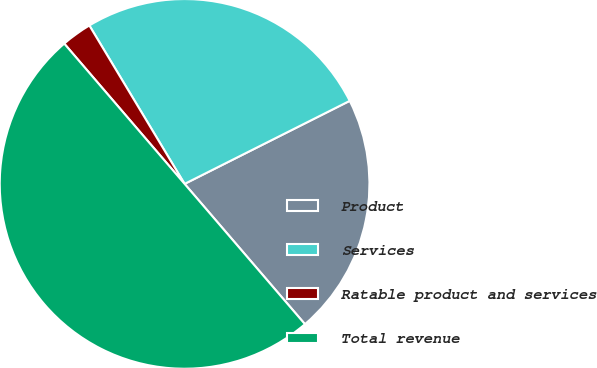Convert chart. <chart><loc_0><loc_0><loc_500><loc_500><pie_chart><fcel>Product<fcel>Services<fcel>Ratable product and services<fcel>Total revenue<nl><fcel>21.13%<fcel>26.2%<fcel>2.67%<fcel>50.0%<nl></chart> 